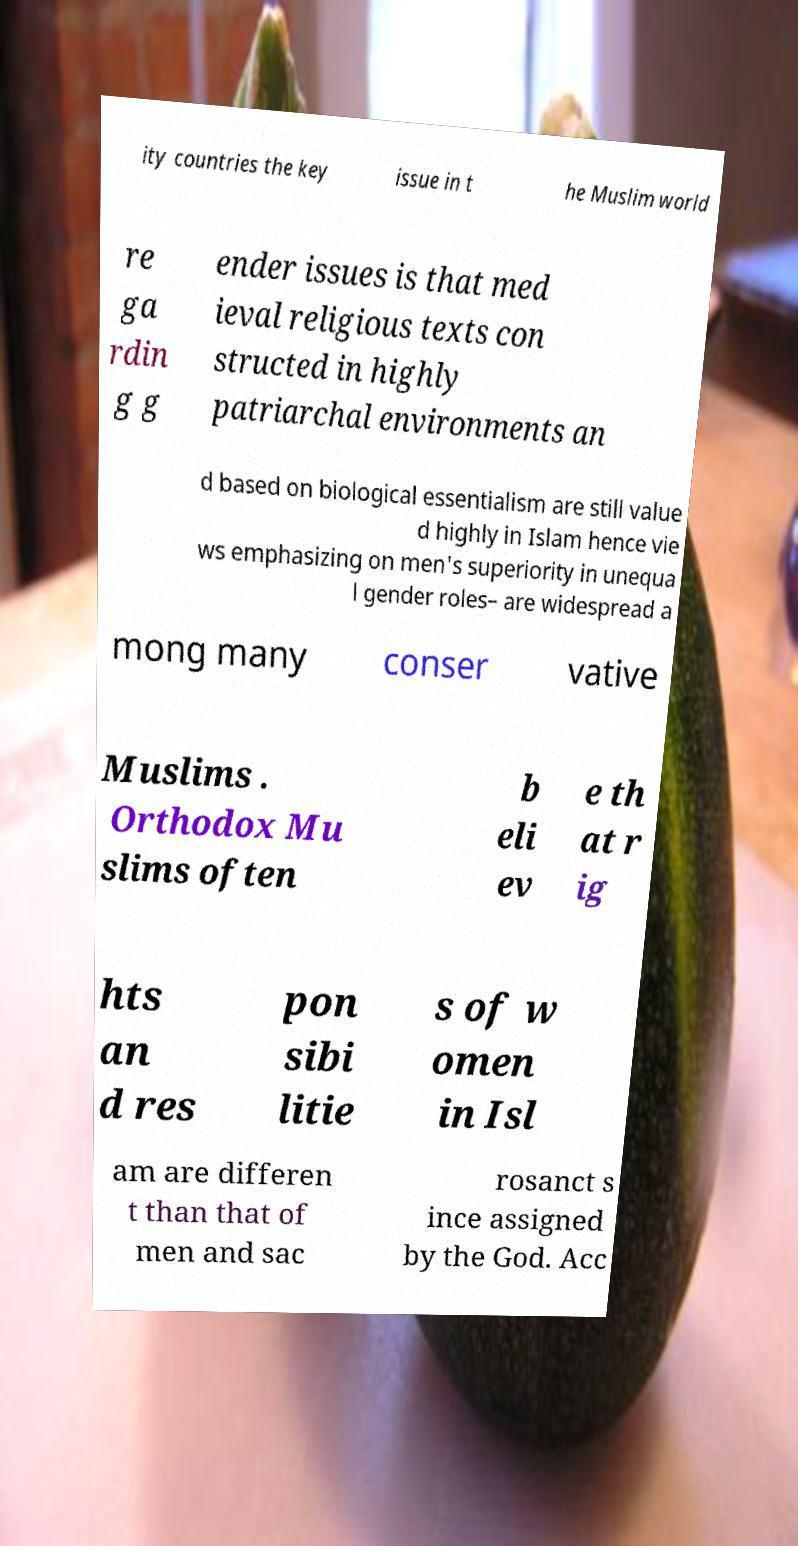For documentation purposes, I need the text within this image transcribed. Could you provide that? ity countries the key issue in t he Muslim world re ga rdin g g ender issues is that med ieval religious texts con structed in highly patriarchal environments an d based on biological essentialism are still value d highly in Islam hence vie ws emphasizing on men's superiority in unequa l gender roles– are widespread a mong many conser vative Muslims . Orthodox Mu slims often b eli ev e th at r ig hts an d res pon sibi litie s of w omen in Isl am are differen t than that of men and sac rosanct s ince assigned by the God. Acc 